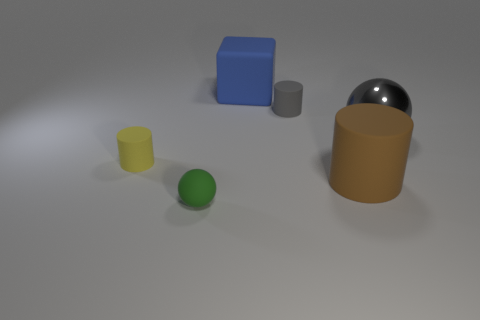Are there an equal number of small gray rubber things that are right of the gray shiny sphere and small blue cylinders?
Offer a terse response. Yes. There is a object that is the same color as the metal sphere; what size is it?
Offer a very short reply. Small. Is there a large brown cylinder that has the same material as the brown thing?
Provide a short and direct response. No. There is a gray object behind the large shiny ball; is it the same shape as the big rubber thing to the right of the big block?
Provide a succinct answer. Yes. Is there a gray rubber cube?
Your answer should be very brief. No. There is a shiny thing that is the same size as the blue matte block; what color is it?
Your answer should be compact. Gray. How many big blue things are the same shape as the big brown object?
Make the answer very short. 0. Is the material of the small cylinder that is right of the small green matte sphere the same as the gray sphere?
Offer a very short reply. No. What number of blocks are green things or big rubber things?
Your response must be concise. 1. There is a large rubber object that is to the right of the large thing that is left of the tiny thing on the right side of the rubber block; what shape is it?
Ensure brevity in your answer.  Cylinder. 